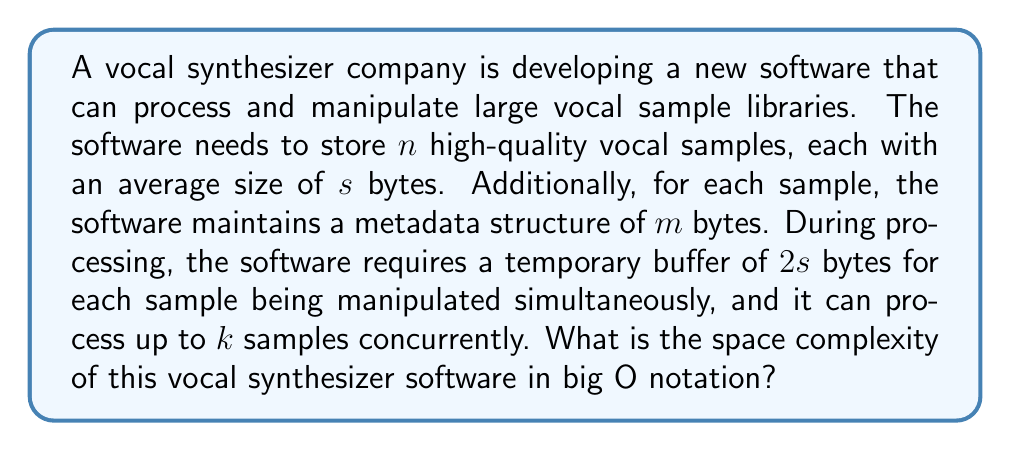Can you solve this math problem? To determine the space complexity, we need to consider all the components that contribute to the space usage:

1. Storage of vocal samples:
   - $n$ samples, each of size $s$ bytes
   - Total space: $n \cdot s$ bytes

2. Metadata for each sample:
   - $n$ metadata structures, each of size $m$ bytes
   - Total space: $n \cdot m$ bytes

3. Temporary processing buffer:
   - $k$ concurrent samples, each requiring $2s$ bytes
   - Total space: $k \cdot 2s$ bytes

The total space required is the sum of these components:

$$ \text{Total Space} = (n \cdot s) + (n \cdot m) + (k \cdot 2s) $$

Simplifying:

$$ \text{Total Space} = n(s + m) + 2ks $$

In big O notation, we focus on the dominant terms as $n$ grows large. Since $k$ is a constant (maximum number of concurrent processes), and $s$ and $m$ are also constants (average sample size and metadata size), we can simplify the expression:

$$ O(n(s + m) + 2ks) = O(n) $$

This is because the term $2ks$ becomes insignificant compared to $n(s + m)$ as $n$ grows large.
Answer: $O(n)$ 